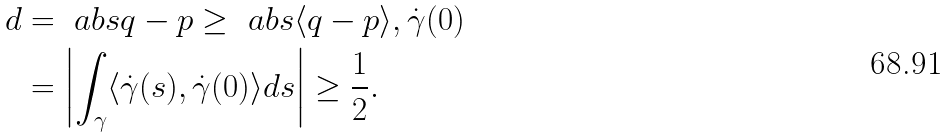<formula> <loc_0><loc_0><loc_500><loc_500>d & = \ a b s { q - p } \geq \ a b s { \langle q - p \rangle , \dot { \gamma } ( 0 ) } \\ & = \left | \int _ { \gamma } \langle \dot { \gamma } ( s ) , \dot { \gamma } ( 0 ) \rangle d s \right | \geq \frac { 1 } { 2 } .</formula> 